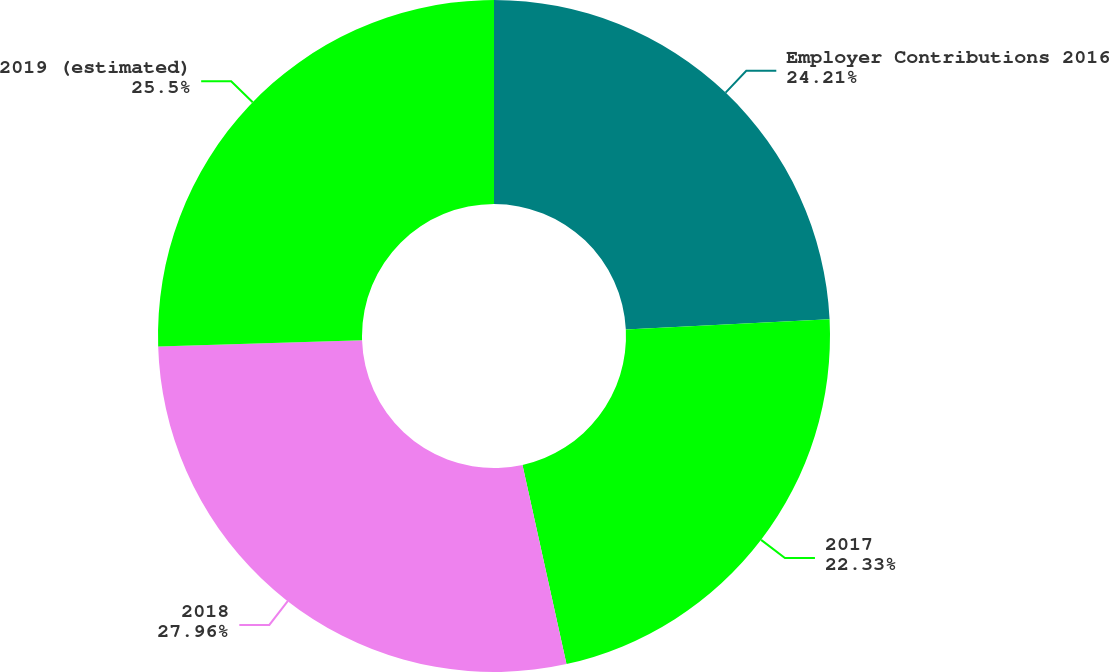<chart> <loc_0><loc_0><loc_500><loc_500><pie_chart><fcel>Employer Contributions 2016<fcel>2017<fcel>2018<fcel>2019 (estimated)<nl><fcel>24.21%<fcel>22.33%<fcel>27.96%<fcel>25.5%<nl></chart> 